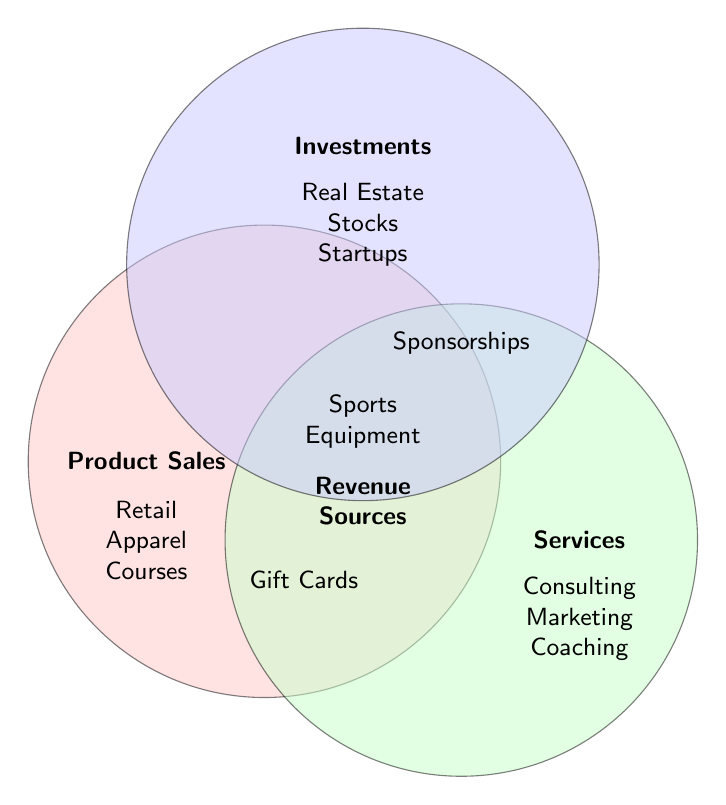What are the main categories depicted in the Venn Diagram? The Venn Diagram shows three main categories: Product Sales, Services, and Investments.
Answer: Product Sales, Services, Investments Which category contains "Retail merchandise"? "Retail merchandise" is within the circle for Product Sales.
Answer: Product Sales How many types of revenue sources are listed under Services? There are three types: Business consulting, Event planning, and Marketing services.
Answer: 3 Is "Cryptocurrencies" a type of Investment? Yes, "Cryptocurrencies" is listed under Investments.
Answer: Yes What revenue sources are common to both Product Sales and Services? None of the revenue sources listed intersect between both Product Sales and Services.
Answer: None Which categories overlap with "Gift cards"? "Gift cards" overlaps between Product Sales, Services, and Investments.
Answer: Product Sales, Services, Investments Among the three circles, which one overlaps with "Sponsorships"? The "Sponsorships" overlaps with all three categories: Product Sales, Services, and Investments.
Answer: All three If you combine Product Sales and Investments, how many unique revenue sources do you get? Product Sales has 8 sources and Investments has 8 sources. Considering overlaps, unique sources are Retail merchandise, Online courses, Sports equipment, Apparel, Memorabilia, Gift cards, Publications, Real estate, Stocks, Bonds, Mutual funds, Venture capital, Cryptocurrencies, Alumni networking, and Startups. So, there are 15 unique sources.
Answer: 15 Which category has more items: Services or Investments? Services has 8 items listed and Investments also has 8 items. They have an equal number of items.
Answer: Equal How many revenue sources are unique to Product Sales? Product Sales has 8 revenue sources: Retail merchandise, Online courses, Sports equipment, Apparel, Memorabilia, Gift cards, and Publications. (Note that Gift cards are mentioned twice but they are counted once).
Answer: 7 